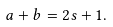Convert formula to latex. <formula><loc_0><loc_0><loc_500><loc_500>a + b = 2 s + 1 .</formula> 